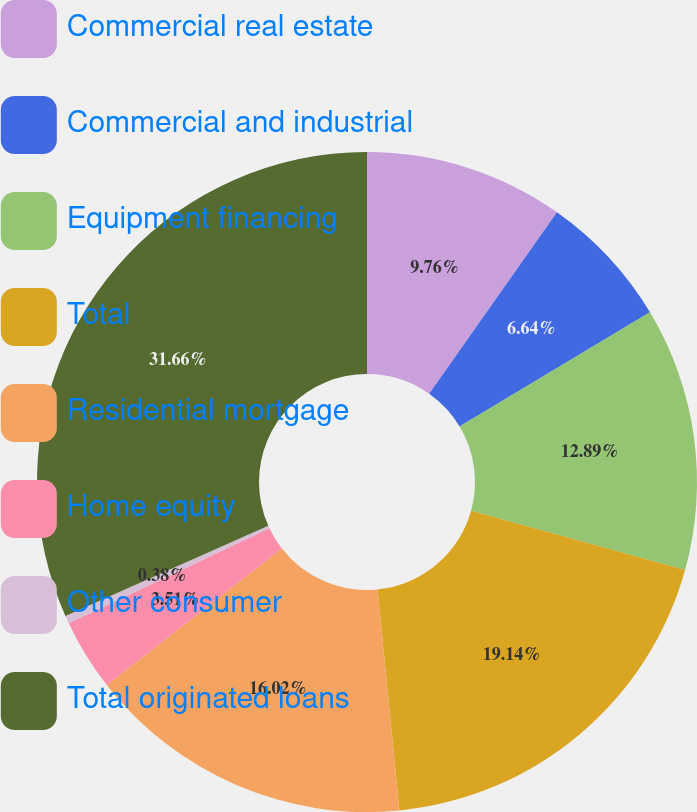<chart> <loc_0><loc_0><loc_500><loc_500><pie_chart><fcel>Commercial real estate<fcel>Commercial and industrial<fcel>Equipment financing<fcel>Total<fcel>Residential mortgage<fcel>Home equity<fcel>Other consumer<fcel>Total originated loans<nl><fcel>9.76%<fcel>6.64%<fcel>12.89%<fcel>19.14%<fcel>16.02%<fcel>3.51%<fcel>0.38%<fcel>31.65%<nl></chart> 